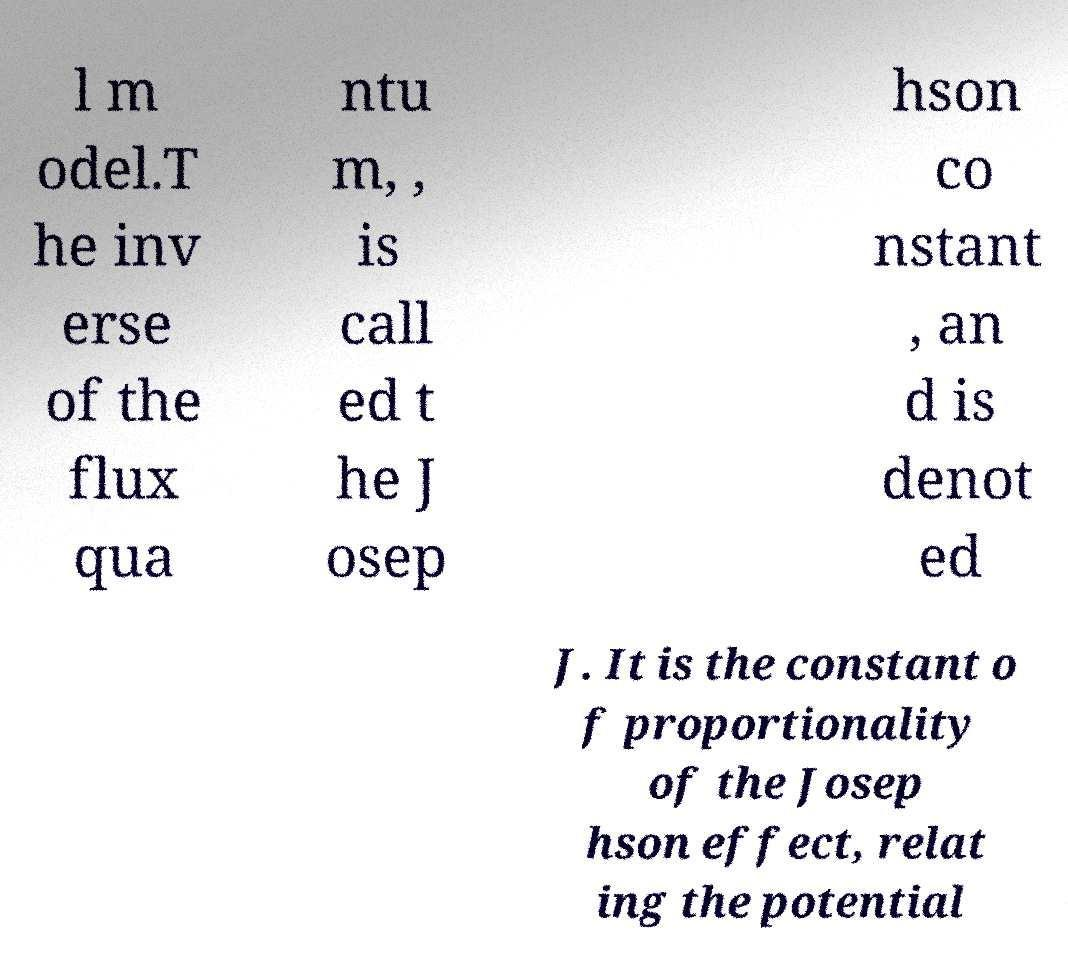Can you accurately transcribe the text from the provided image for me? l m odel.T he inv erse of the flux qua ntu m, , is call ed t he J osep hson co nstant , an d is denot ed J. It is the constant o f proportionality of the Josep hson effect, relat ing the potential 